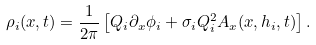Convert formula to latex. <formula><loc_0><loc_0><loc_500><loc_500>\rho _ { i } ( x , t ) = \frac { 1 } { 2 \pi } \left [ Q _ { i } \partial _ { x } \phi _ { i } + \sigma _ { i } Q _ { i } ^ { 2 } A _ { x } ( x , h _ { i } , t ) \right ] .</formula> 